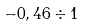Convert formula to latex. <formula><loc_0><loc_0><loc_500><loc_500>- 0 , 4 6 \div 1</formula> 